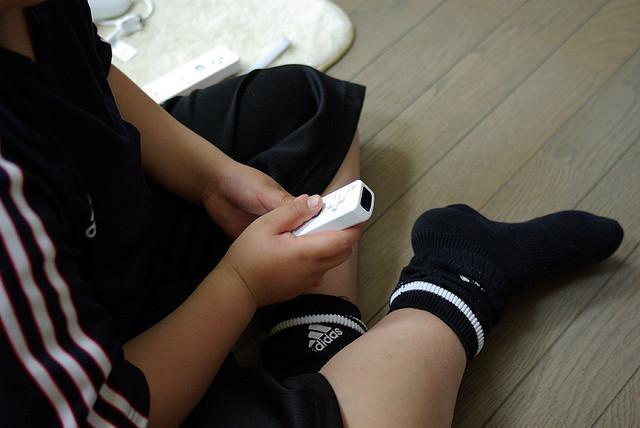How many remotes are there?
Give a very brief answer. 2. How many horses are to the left of the light pole?
Give a very brief answer. 0. 